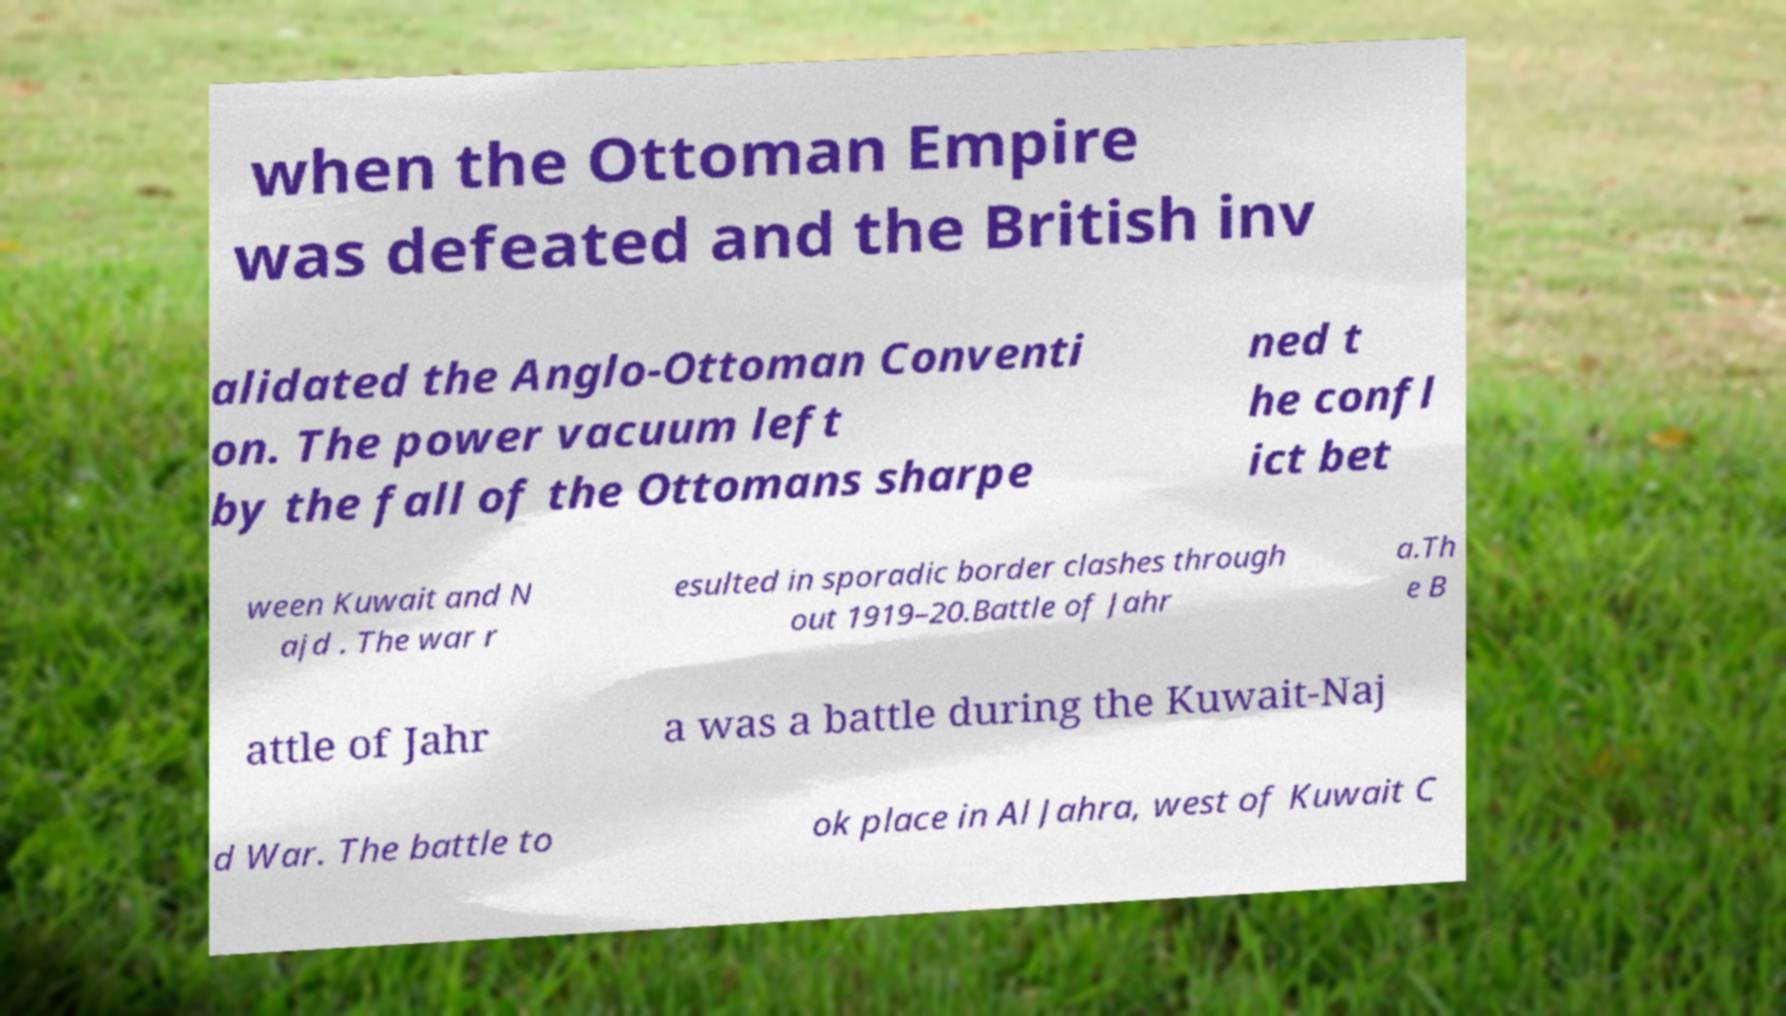What messages or text are displayed in this image? I need them in a readable, typed format. when the Ottoman Empire was defeated and the British inv alidated the Anglo-Ottoman Conventi on. The power vacuum left by the fall of the Ottomans sharpe ned t he confl ict bet ween Kuwait and N ajd . The war r esulted in sporadic border clashes through out 1919–20.Battle of Jahr a.Th e B attle of Jahr a was a battle during the Kuwait-Naj d War. The battle to ok place in Al Jahra, west of Kuwait C 